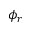Convert formula to latex. <formula><loc_0><loc_0><loc_500><loc_500>\phi _ { r }</formula> 